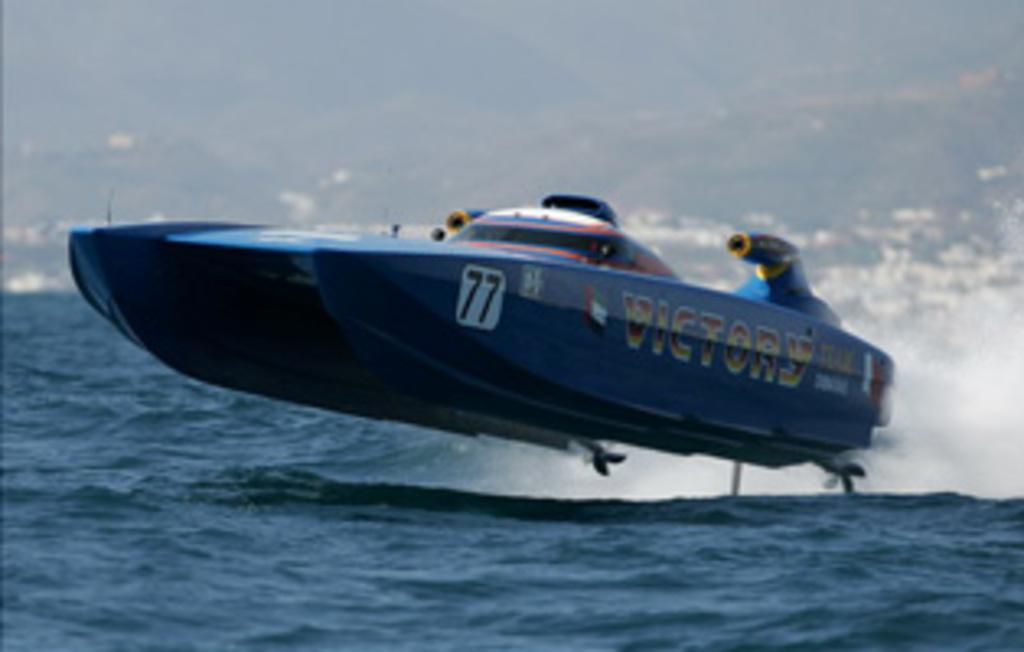What is the main subject of the image? The main subject of the image is a boat. Can you describe the boat's position in relation to the water? The boat is above the water in the image. What can be observed about the background of the image? The background of the image is blurry. What type of knife is being used by the person in the boat? There is no person or knife visible in the image; it only features a boat above the water with a blurry background. 